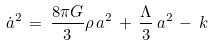Convert formula to latex. <formula><loc_0><loc_0><loc_500><loc_500>\dot { a } ^ { 2 } \, = \, \frac { 8 \pi G } { 3 } \rho \, a ^ { 2 } \, + \, \frac { \Lambda } { 3 } \, a ^ { 2 } \, - \, k</formula> 